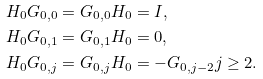<formula> <loc_0><loc_0><loc_500><loc_500>H _ { 0 } G _ { 0 , 0 } & = G _ { 0 , 0 } H _ { 0 } = I , \\ H _ { 0 } G _ { 0 , 1 } & = G _ { 0 , 1 } H _ { 0 } = 0 , \\ H _ { 0 } G _ { 0 , j } & = G _ { 0 , j } H _ { 0 } = - G _ { 0 , j - 2 } j \geq 2 .</formula> 